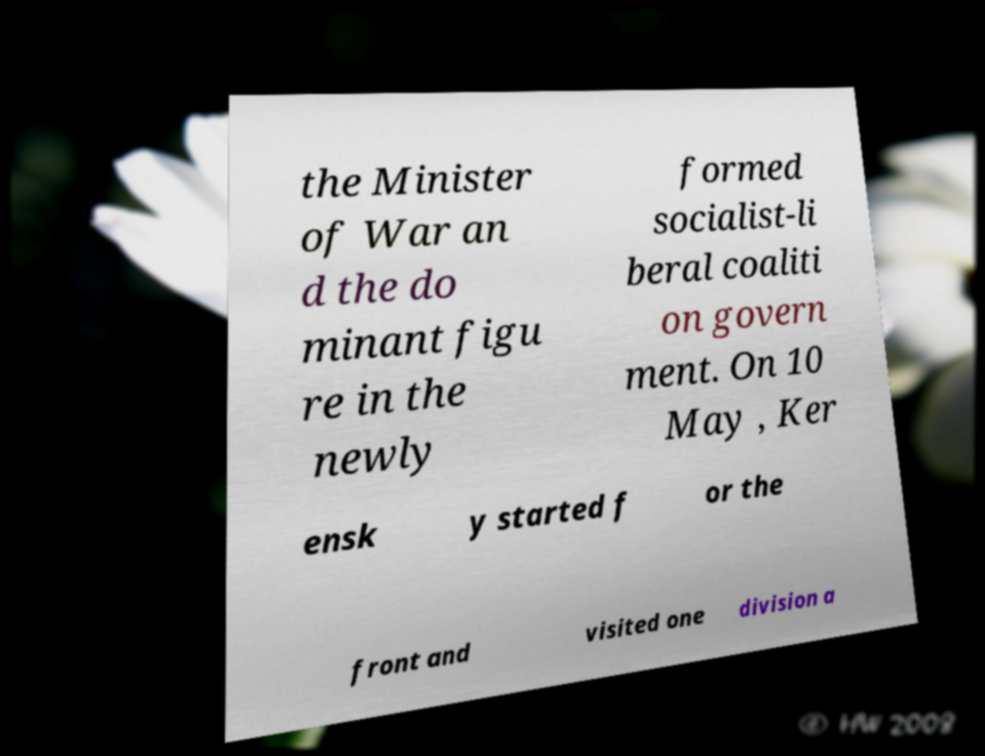For documentation purposes, I need the text within this image transcribed. Could you provide that? the Minister of War an d the do minant figu re in the newly formed socialist-li beral coaliti on govern ment. On 10 May , Ker ensk y started f or the front and visited one division a 